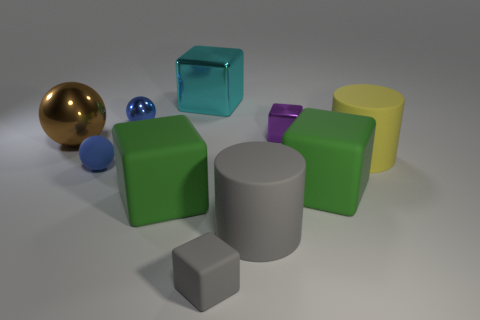Do the tiny matte ball and the small shiny sphere have the same color?
Offer a very short reply. Yes. What material is the large cube that is to the left of the large cyan shiny block?
Offer a terse response. Rubber. Is the tiny blue sphere behind the yellow thing made of the same material as the blue sphere that is in front of the yellow thing?
Give a very brief answer. No. Are there an equal number of large green rubber blocks that are right of the brown sphere and gray blocks right of the big gray object?
Give a very brief answer. No. How many small blue things have the same material as the big brown sphere?
Give a very brief answer. 1. There is a big matte thing that is the same color as the tiny rubber block; what shape is it?
Your answer should be very brief. Cylinder. What is the size of the blue sphere that is behind the metal ball to the left of the small metallic ball?
Keep it short and to the point. Small. There is a large green matte object to the right of the large cyan block; is its shape the same as the tiny rubber thing that is in front of the blue rubber object?
Your answer should be compact. Yes. Are there an equal number of purple things that are to the left of the large brown ball and gray matte cubes?
Offer a terse response. No. What is the color of the other large thing that is the same shape as the yellow thing?
Your answer should be very brief. Gray. 